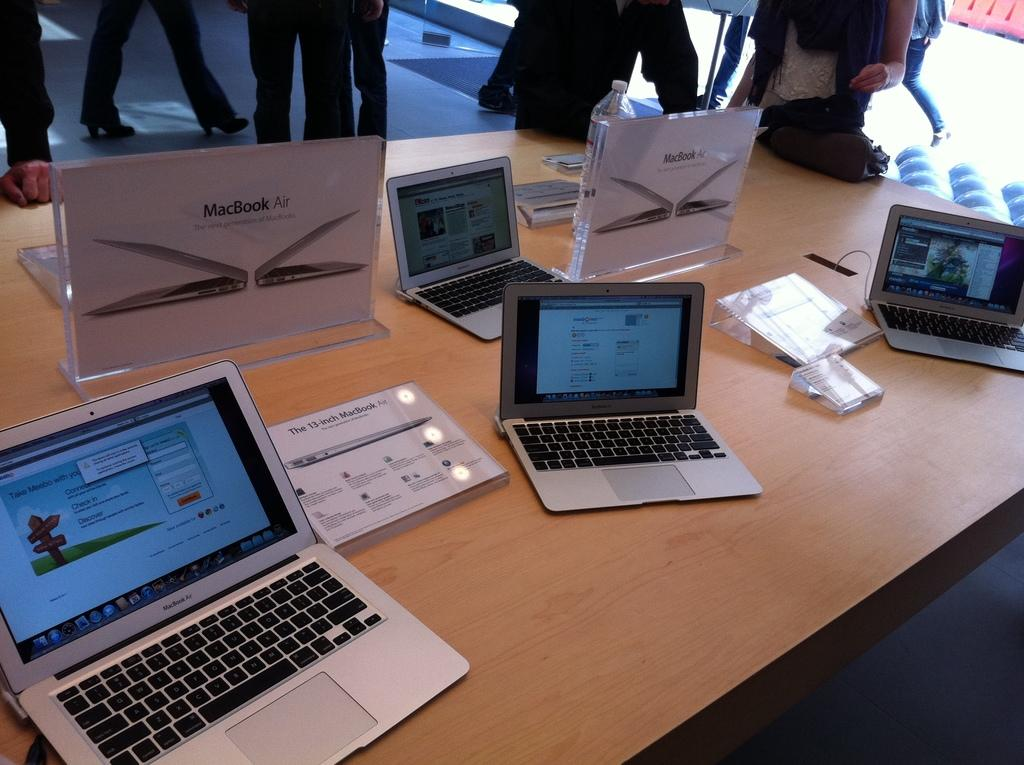Provide a one-sentence caption for the provided image. four macbook airs on display, with placards reading specs. 